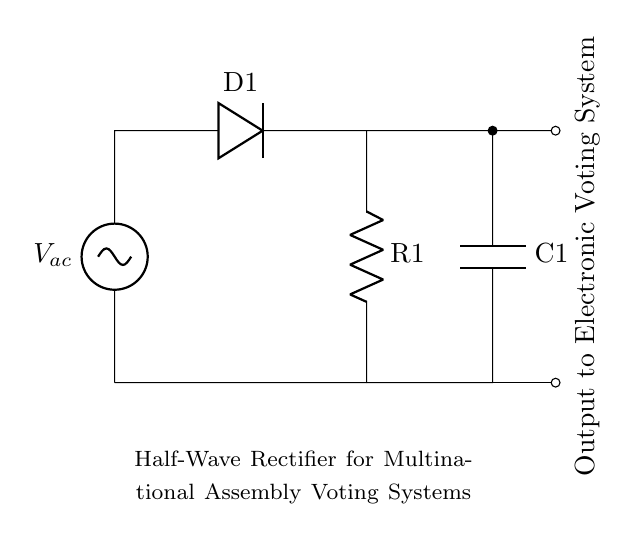What type of rectifier is shown in the diagram? The diagram depicts a half-wave rectifier, characterized by the presence of a single diode allowing current to flow in one direction only.
Answer: half-wave rectifier What is the function of diode D1 in this circuit? The diode D1 allows current to pass during the positive half-cycle of the AC voltage while blocking it during the negative half-cycle, converting AC to DC.
Answer: converts AC to DC How many components are actively involved in delivering power to the electronic voting system? The components actively involved are the diode and the resistor, which work together to rectify and manage the power delivery.
Answer: two What voltage source is used in this half-wave rectifier circuit? The voltage source shown is labeled as V_ac, indicating it is an alternating current (AC) source, typical for such applications.
Answer: V_ac What is the role of capacitor C1 in the circuit? Capacitor C1 smooths the output voltage by storing charge and releasing it to maintain a steady voltage, especially during periods when the diode is not conducting.
Answer: smooths output voltage What happens to the current during the negative half-cycle of the input AC voltage? During the negative half-cycle, the diode D1 becomes reverse-biased and blocks current flow, resulting in zero output current.
Answer: zero output current What does the label "Output to Electronic Voting System" signify? This label indicates that the rectified and smoothed DC voltage is directed to the electronic voting system, providing it with the necessary power for operation.
Answer: necessary power for operation 